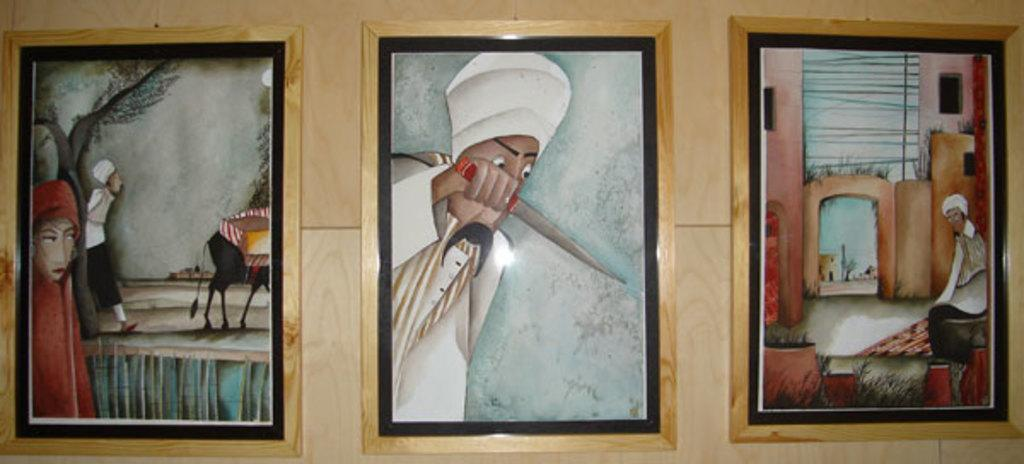What is on the wooden wall in the image? There are three frames on the wooden wall in the image. What can be found inside the frames? The frames contain paintings. What subjects are depicted in the paintings? The paintings depict a few people, one animal, and a few other objects. How does the heat affect the paintings in the image? There is no mention of heat in the image, so we cannot determine its effect on the paintings. Is there a note attached to any of the paintings in the image? There is no mention of a note in the image, so we cannot determine if one is attached to any of the paintings. 